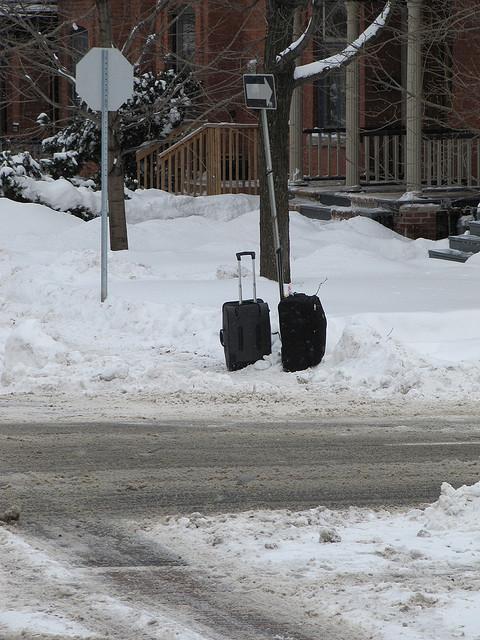How many people are in this image?
Keep it brief. 0. Did someone forget his luggage in the snow?
Keep it brief. Yes. Has the road been scraped?
Short answer required. Yes. 